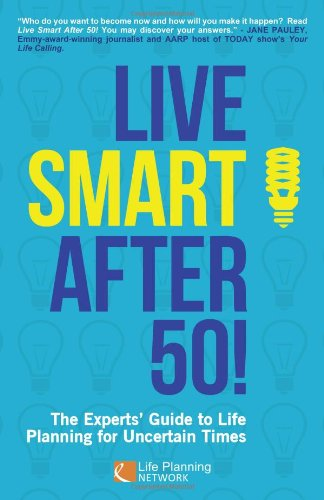Who is this book primarily targeted towards? This book targets individuals who are near or have already reached the age of 50, providing them strategies to manage life changes and uncertain times efficiently. 